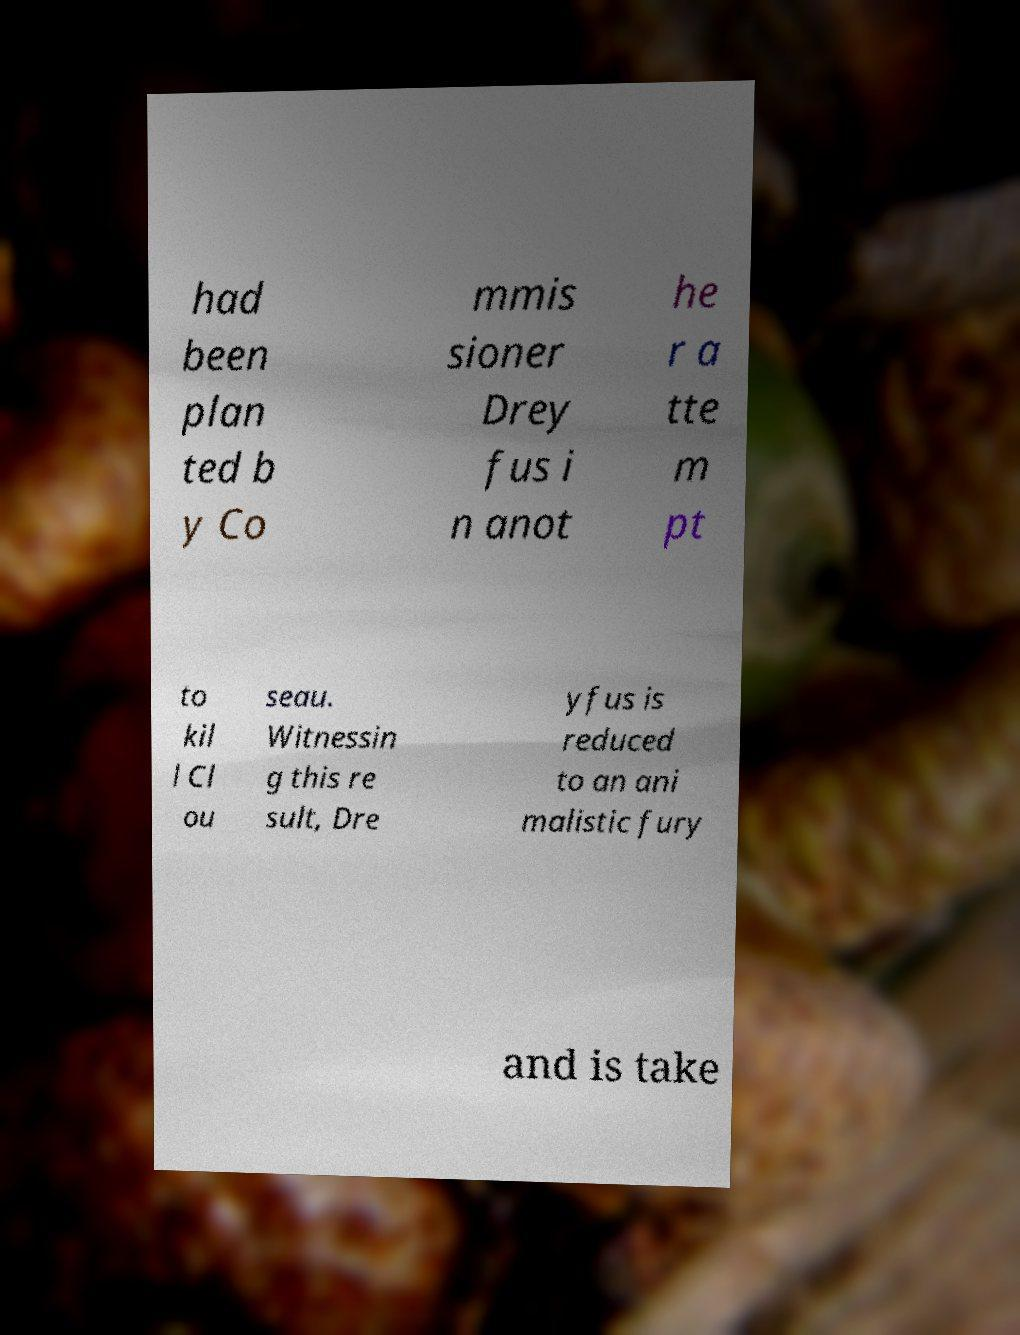There's text embedded in this image that I need extracted. Can you transcribe it verbatim? had been plan ted b y Co mmis sioner Drey fus i n anot he r a tte m pt to kil l Cl ou seau. Witnessin g this re sult, Dre yfus is reduced to an ani malistic fury and is take 